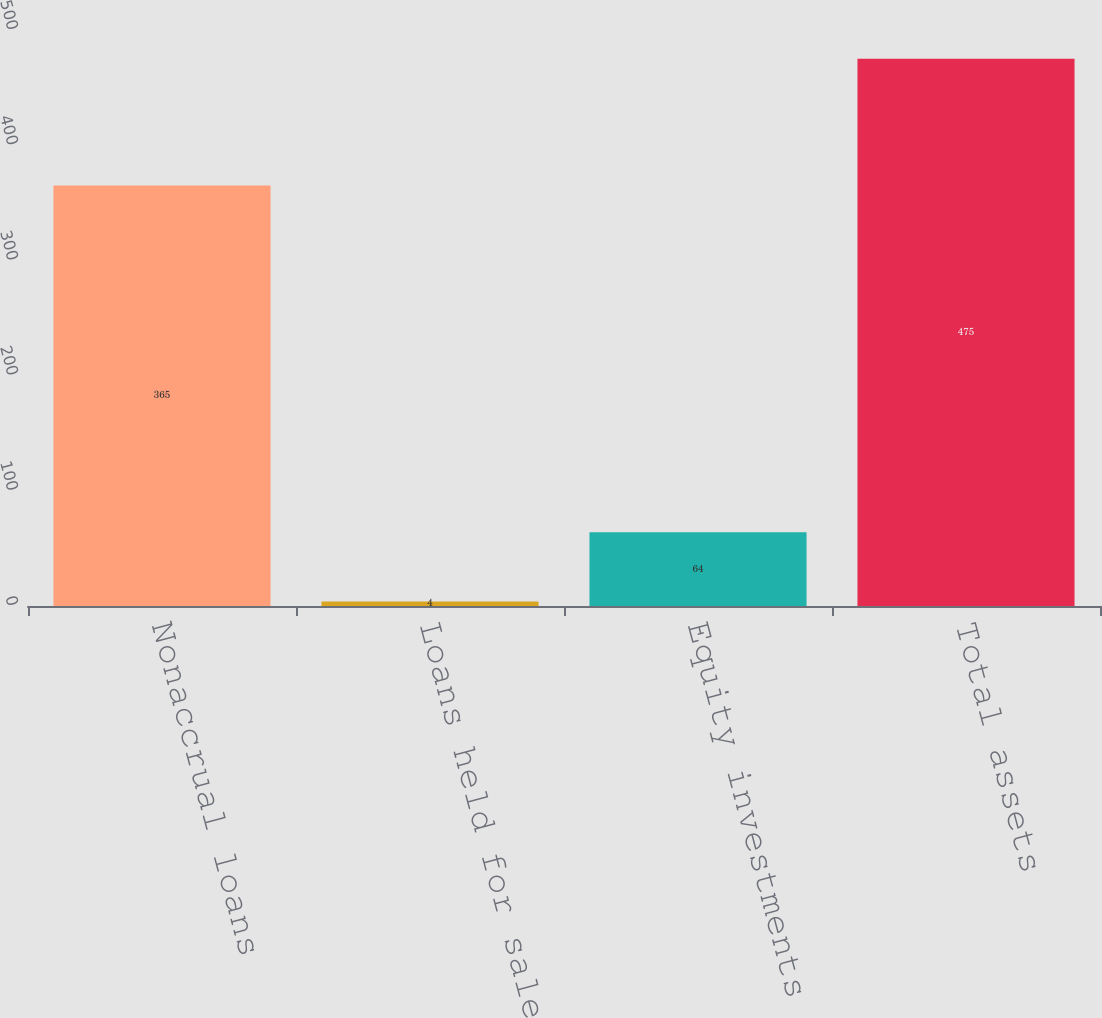Convert chart to OTSL. <chart><loc_0><loc_0><loc_500><loc_500><bar_chart><fcel>Nonaccrual loans<fcel>Loans held for sale<fcel>Equity investments (b)<fcel>Total assets<nl><fcel>365<fcel>4<fcel>64<fcel>475<nl></chart> 